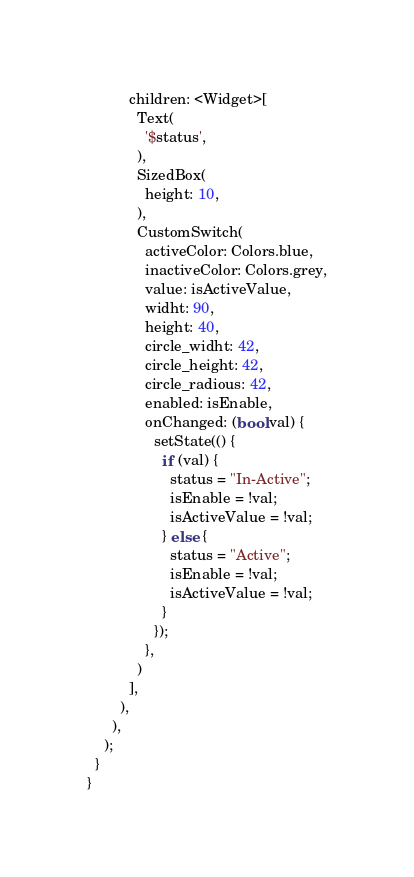Convert code to text. <code><loc_0><loc_0><loc_500><loc_500><_Dart_>          children: <Widget>[
            Text(
              '$status',
            ),
            SizedBox(
              height: 10,
            ),
            CustomSwitch(
              activeColor: Colors.blue,
              inactiveColor: Colors.grey,
              value: isActiveValue,
              widht: 90,
              height: 40,
              circle_widht: 42,
              circle_height: 42,
              circle_radious: 42,
              enabled: isEnable,
              onChanged: (bool val) {
                setState(() {
                  if (val) {
                    status = "In-Active";
                    isEnable = !val;
                    isActiveValue = !val;
                  } else {
                    status = "Active";
                    isEnable = !val;
                    isActiveValue = !val;
                  }
                });
              },
            )
          ],
        ),
      ),
    );
  }
}
</code> 